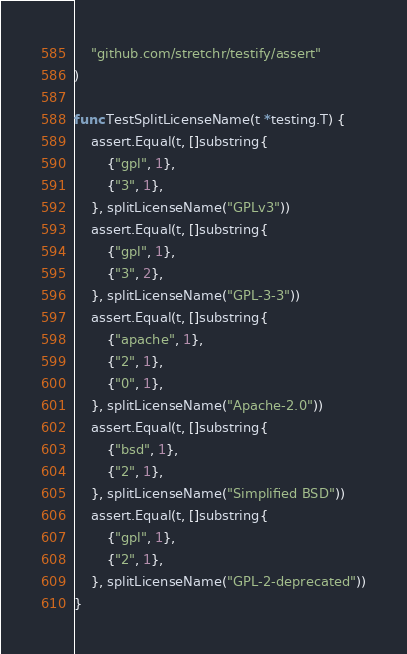Convert code to text. <code><loc_0><loc_0><loc_500><loc_500><_Go_>
	"github.com/stretchr/testify/assert"
)

func TestSplitLicenseName(t *testing.T) {
	assert.Equal(t, []substring{
		{"gpl", 1},
		{"3", 1},
	}, splitLicenseName("GPLv3"))
	assert.Equal(t, []substring{
		{"gpl", 1},
		{"3", 2},
	}, splitLicenseName("GPL-3-3"))
	assert.Equal(t, []substring{
		{"apache", 1},
		{"2", 1},
		{"0", 1},
	}, splitLicenseName("Apache-2.0"))
	assert.Equal(t, []substring{
		{"bsd", 1},
		{"2", 1},
	}, splitLicenseName("Simplified BSD"))
	assert.Equal(t, []substring{
		{"gpl", 1},
		{"2", 1},
	}, splitLicenseName("GPL-2-deprecated"))
}
</code> 